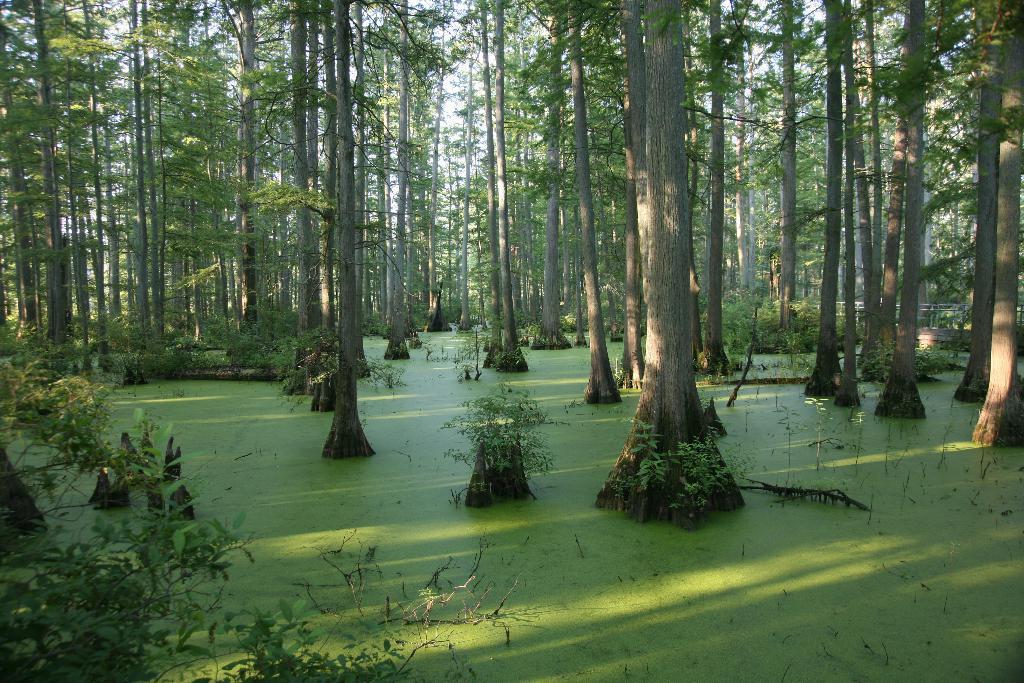In one or two sentences, can you explain what this image depicts? In this image I can see the water which are green in color and few trees which are green and grey in color on the surface of the water. In the background I can see the sky. 